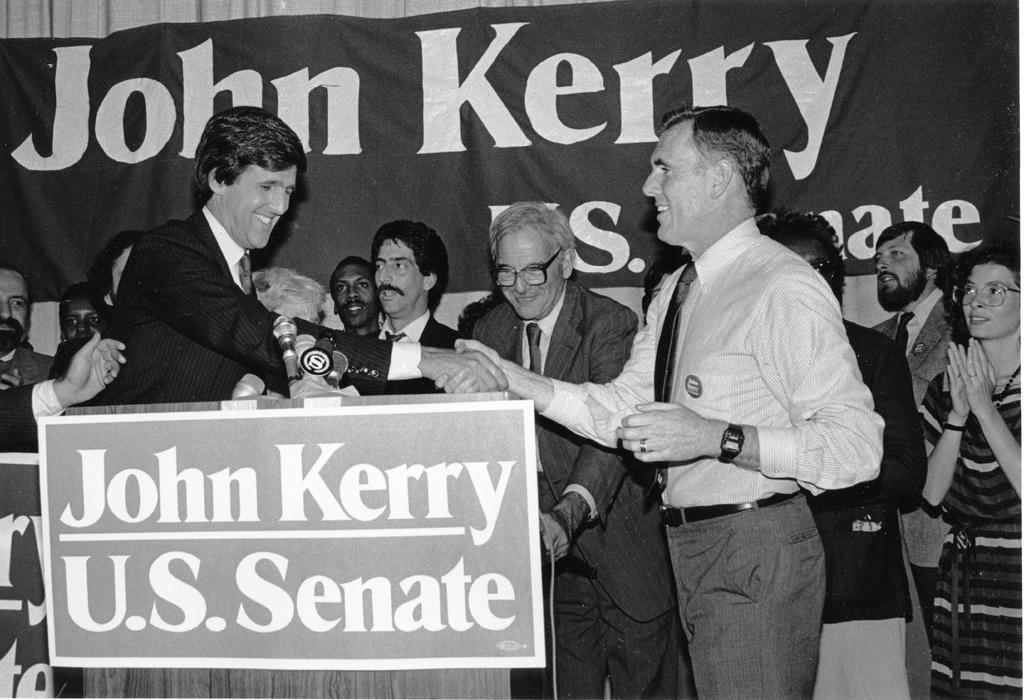Describe this image in one or two sentences. In this image we can see a group of people. In the front of the image there are people who are shaking their hands. Behind the persons we can see a cloth with a text and to the front of them, we have a wooden material to which a board is attached which have a text on it. 